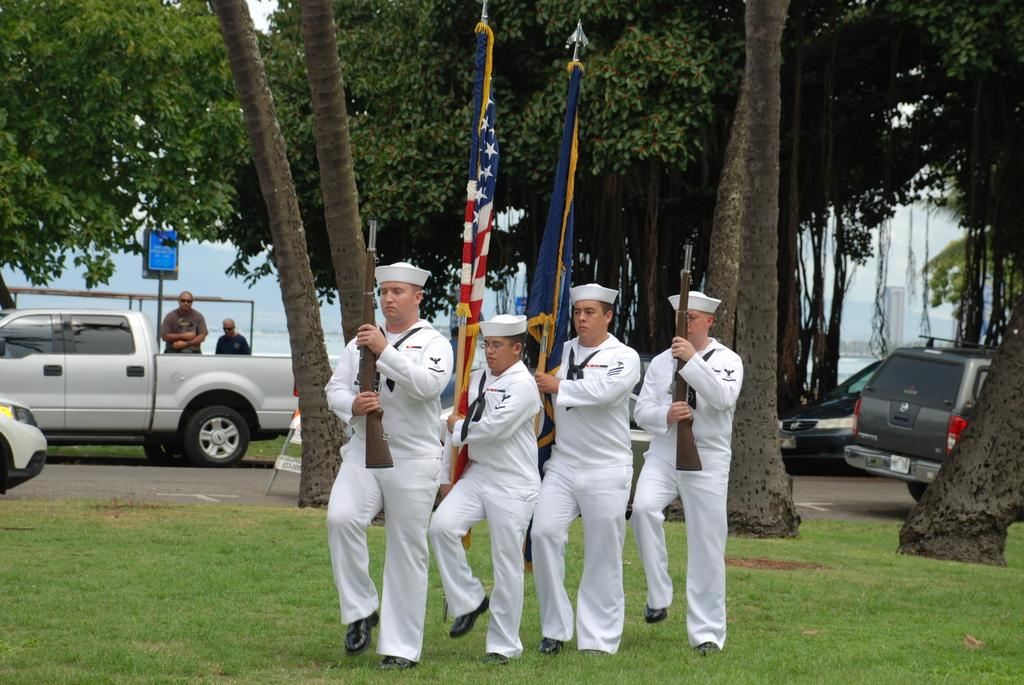How many men are present in the image? There are four men in the image. What are the men wearing? The men are wearing white dress. What are the men holding in their hands? The men are holding guns. What is the terrain where the men are marching? The men are marching on grass land. What can be seen in the background of the image? There are trees, cars, and a sea visible in the background of the image. What book is the man in the middle reading while marching? There is no book present in the image; the men are holding guns and marching. What mark can be seen on the grass where the men are marching? There is no specific mark mentioned in the image; the men are marching on grass land. 